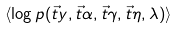Convert formula to latex. <formula><loc_0><loc_0><loc_500><loc_500>\langle \log p ( \vec { t } { y } , \vec { t } { \alpha } , \vec { t } { \gamma } , \vec { t } { \eta } , \lambda ) \rangle</formula> 